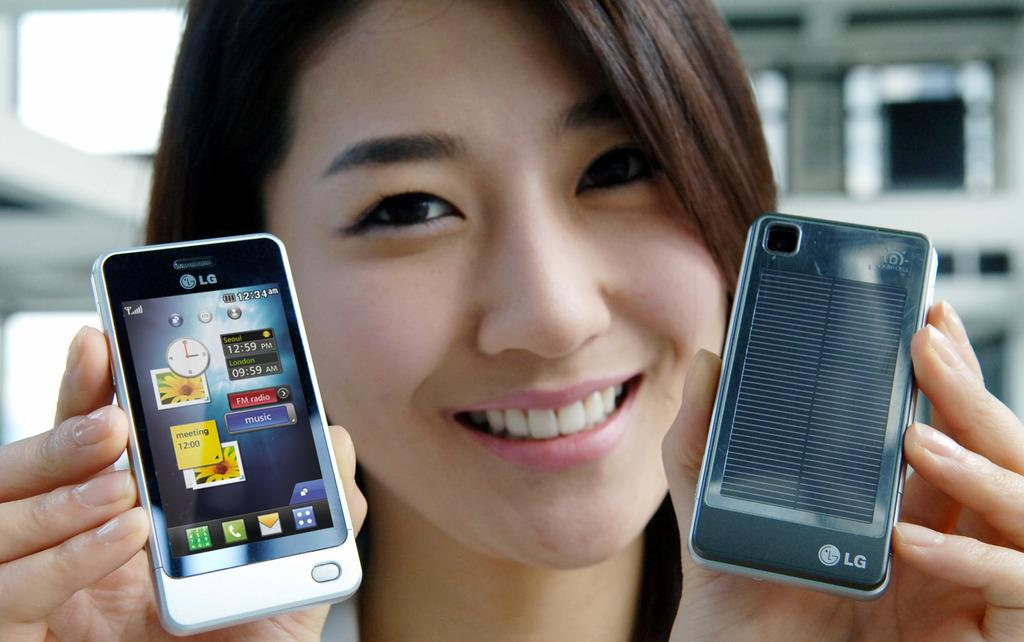Provide a one-sentence caption for the provided image. A lady holding up two cell phones which are both made by LG. 